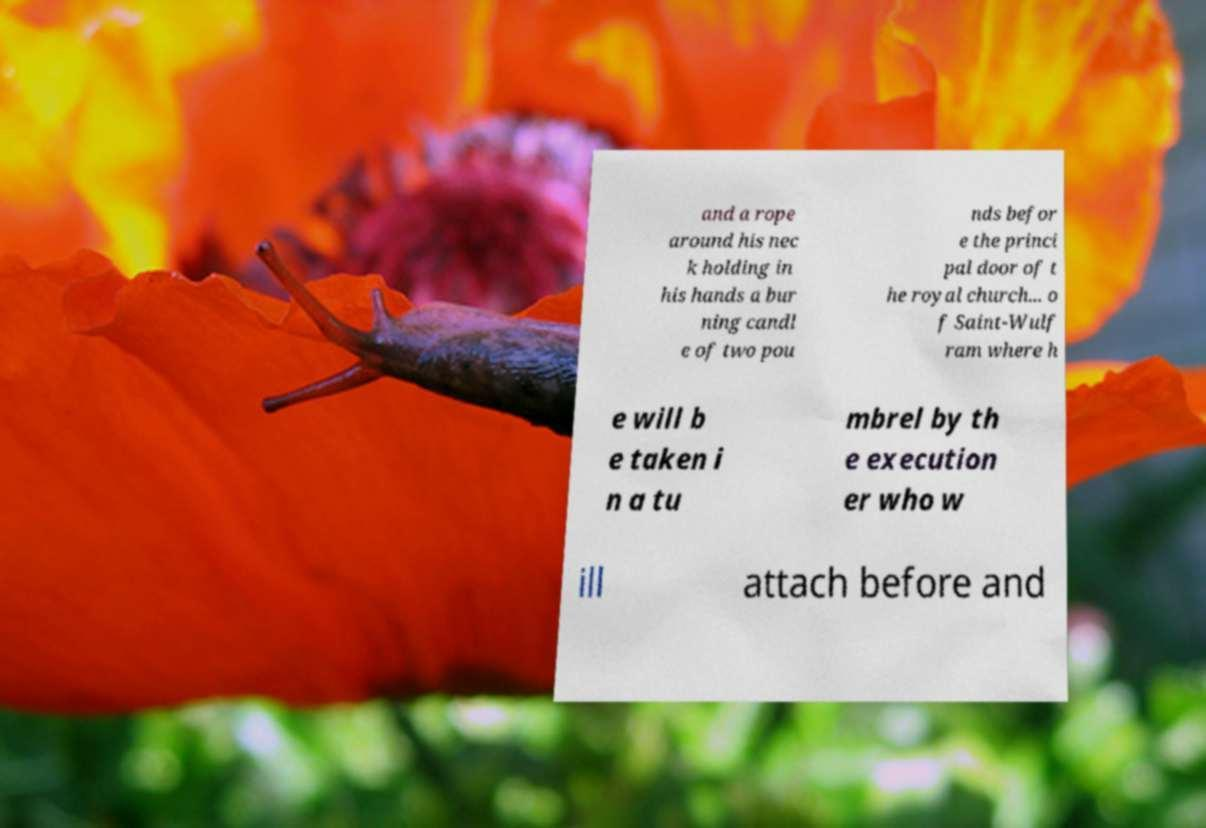I need the written content from this picture converted into text. Can you do that? and a rope around his nec k holding in his hands a bur ning candl e of two pou nds befor e the princi pal door of t he royal church... o f Saint-Wulf ram where h e will b e taken i n a tu mbrel by th e execution er who w ill attach before and 